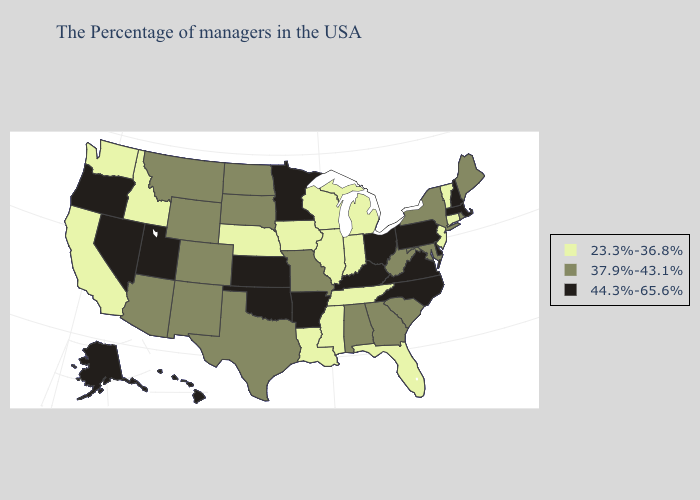Name the states that have a value in the range 37.9%-43.1%?
Write a very short answer. Maine, Rhode Island, New York, Maryland, South Carolina, West Virginia, Georgia, Alabama, Missouri, Texas, South Dakota, North Dakota, Wyoming, Colorado, New Mexico, Montana, Arizona. Name the states that have a value in the range 37.9%-43.1%?
Quick response, please. Maine, Rhode Island, New York, Maryland, South Carolina, West Virginia, Georgia, Alabama, Missouri, Texas, South Dakota, North Dakota, Wyoming, Colorado, New Mexico, Montana, Arizona. Does Wisconsin have a lower value than Tennessee?
Keep it brief. No. Name the states that have a value in the range 23.3%-36.8%?
Give a very brief answer. Vermont, Connecticut, New Jersey, Florida, Michigan, Indiana, Tennessee, Wisconsin, Illinois, Mississippi, Louisiana, Iowa, Nebraska, Idaho, California, Washington. What is the value of Massachusetts?
Be succinct. 44.3%-65.6%. Name the states that have a value in the range 23.3%-36.8%?
Concise answer only. Vermont, Connecticut, New Jersey, Florida, Michigan, Indiana, Tennessee, Wisconsin, Illinois, Mississippi, Louisiana, Iowa, Nebraska, Idaho, California, Washington. Does Maryland have the same value as New York?
Give a very brief answer. Yes. Does Washington have the highest value in the West?
Quick response, please. No. Among the states that border Iowa , which have the lowest value?
Quick response, please. Wisconsin, Illinois, Nebraska. Name the states that have a value in the range 44.3%-65.6%?
Keep it brief. Massachusetts, New Hampshire, Delaware, Pennsylvania, Virginia, North Carolina, Ohio, Kentucky, Arkansas, Minnesota, Kansas, Oklahoma, Utah, Nevada, Oregon, Alaska, Hawaii. Does Ohio have the lowest value in the MidWest?
Short answer required. No. What is the lowest value in states that border Massachusetts?
Keep it brief. 23.3%-36.8%. Which states have the lowest value in the South?
Answer briefly. Florida, Tennessee, Mississippi, Louisiana. What is the value of Illinois?
Quick response, please. 23.3%-36.8%. 